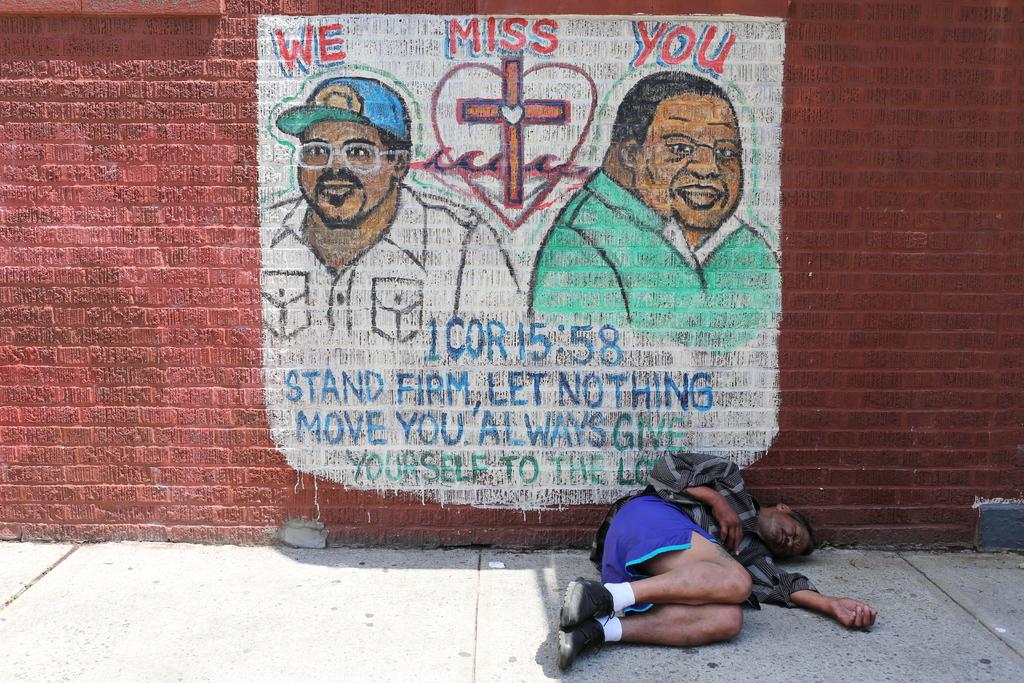Who misses you?
Ensure brevity in your answer.  We. What should you let nothing do?
Provide a succinct answer. Move you. 